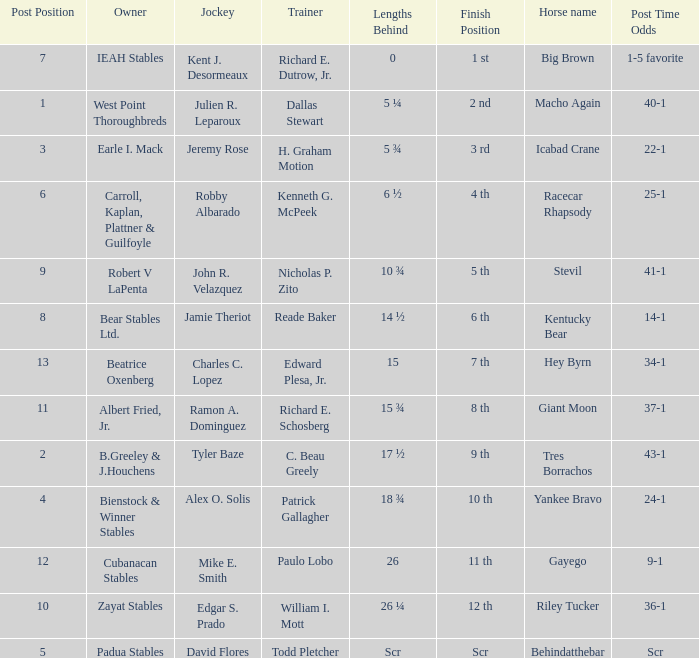What is the lengths behind of Jeremy Rose? 5 ¾. 